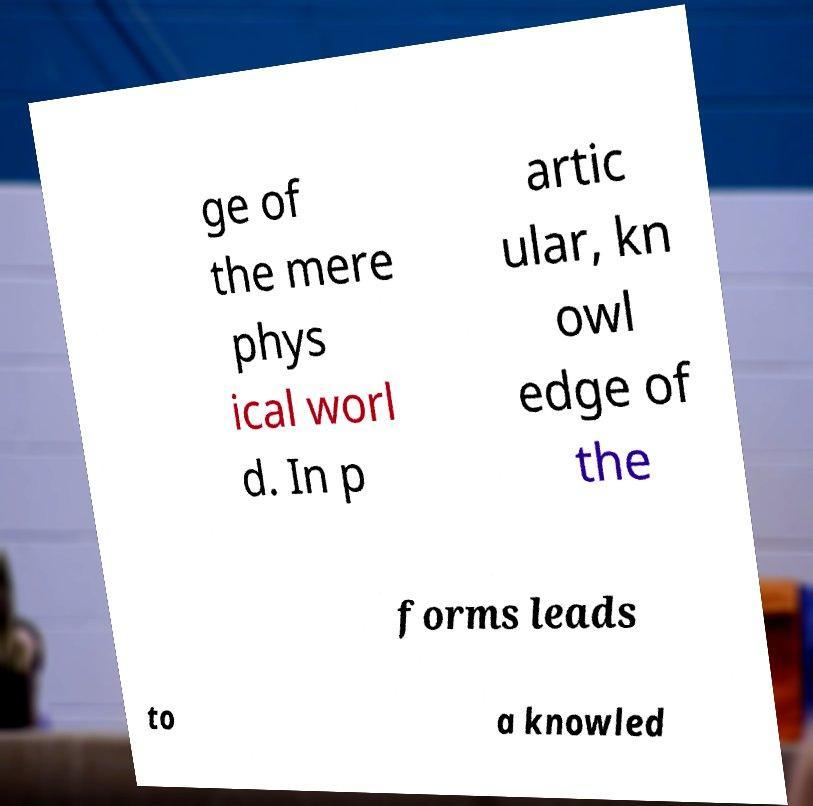There's text embedded in this image that I need extracted. Can you transcribe it verbatim? ge of the mere phys ical worl d. In p artic ular, kn owl edge of the forms leads to a knowled 